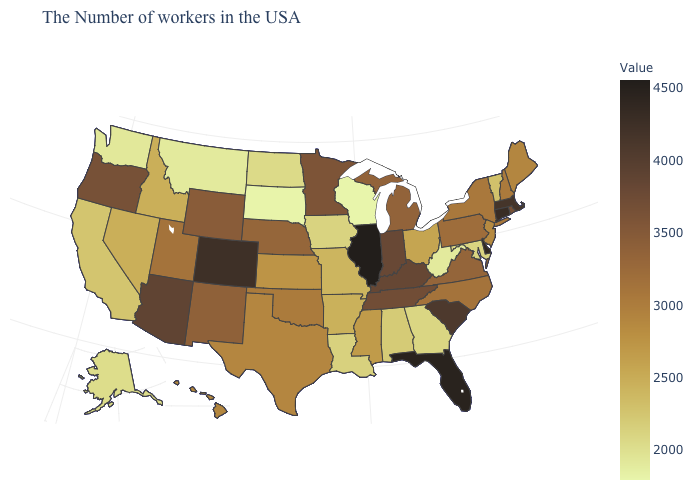Which states have the lowest value in the MidWest?
Keep it brief. Wisconsin. Which states hav the highest value in the MidWest?
Keep it brief. Illinois. Which states hav the highest value in the Northeast?
Quick response, please. Connecticut. Which states have the lowest value in the MidWest?
Concise answer only. Wisconsin. Which states hav the highest value in the Northeast?
Concise answer only. Connecticut. Which states have the lowest value in the USA?
Concise answer only. Wisconsin. 